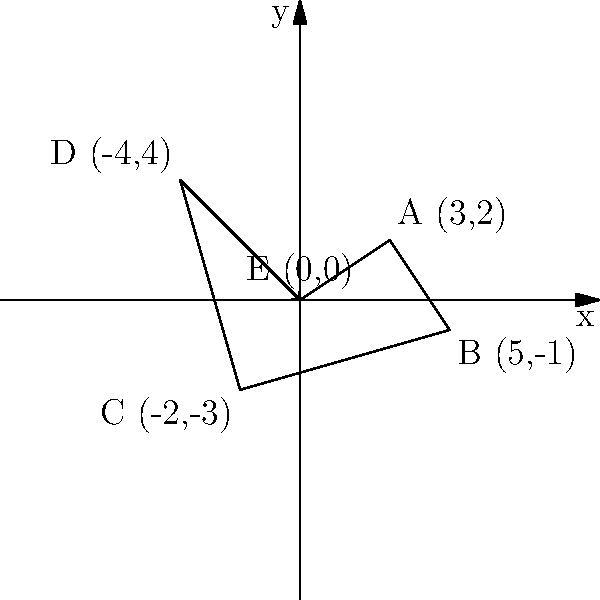During a tennis rally at a Grand Slam event, a player's movement is tracked and plotted on a coordinate system. The player starts at point E (0,0), moves to A (3,2), then B (5,-1), C (-2,-3), D (-4,4), and finally returns to E (0,0). What is the total distance traveled by the player, rounded to the nearest whole number? To find the total distance traveled, we need to calculate the distance between each consecutive point and sum them up. We'll use the distance formula: $d = \sqrt{(x_2-x_1)^2 + (y_2-y_1)^2}$

1. Distance from E to A:
   $d_{EA} = \sqrt{(3-0)^2 + (2-0)^2} = \sqrt{9 + 4} = \sqrt{13} \approx 3.61$

2. Distance from A to B:
   $d_{AB} = \sqrt{(5-3)^2 + (-1-2)^2} = \sqrt{4 + 9} = \sqrt{13} \approx 3.61$

3. Distance from B to C:
   $d_{BC} = \sqrt{(-2-5)^2 + (-3-(-1))^2} = \sqrt{49 + 4} = \sqrt{53} \approx 7.28$

4. Distance from C to D:
   $d_{CD} = \sqrt{(-4-(-2))^2 + (4-(-3))^2} = \sqrt{4 + 49} = \sqrt{53} \approx 7.28$

5. Distance from D to E:
   $d_{DE} = \sqrt{(0-(-4))^2 + (0-4)^2} = \sqrt{16 + 16} = \sqrt{32} \approx 5.66$

Total distance = $d_{EA} + d_{AB} + d_{BC} + d_{CD} + d_{DE}$
$\approx 3.61 + 3.61 + 7.28 + 7.28 + 5.66 = 27.44$

Rounding to the nearest whole number: 27
Answer: 27 